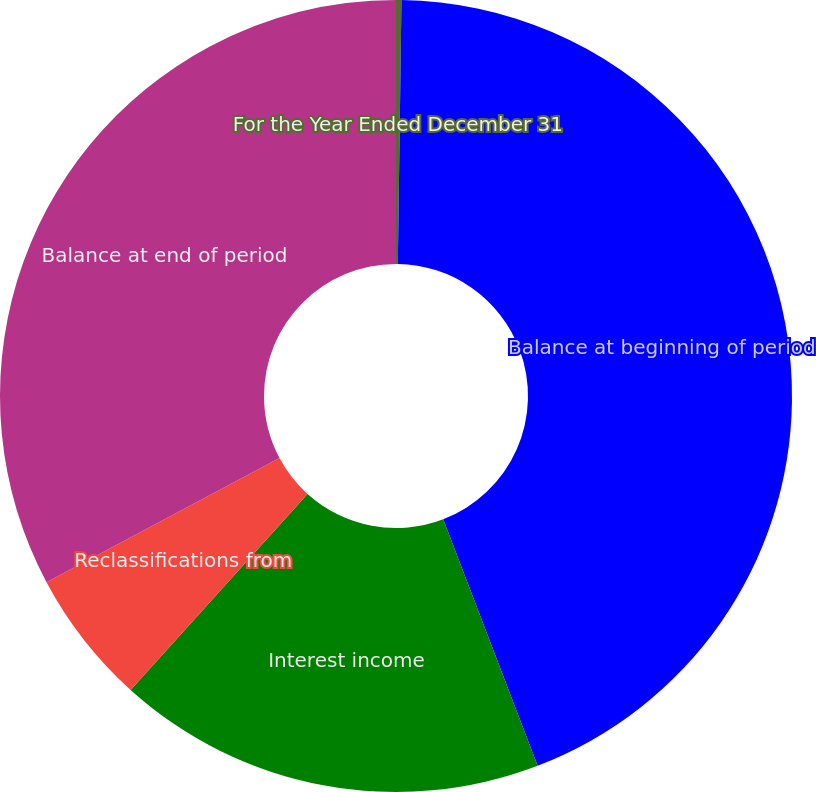<chart> <loc_0><loc_0><loc_500><loc_500><pie_chart><fcel>For the Year Ended December 31<fcel>Balance at beginning of period<fcel>Interest income<fcel>Reclassifications from<fcel>Balance at end of period<nl><fcel>0.22%<fcel>43.96%<fcel>17.51%<fcel>5.52%<fcel>32.79%<nl></chart> 